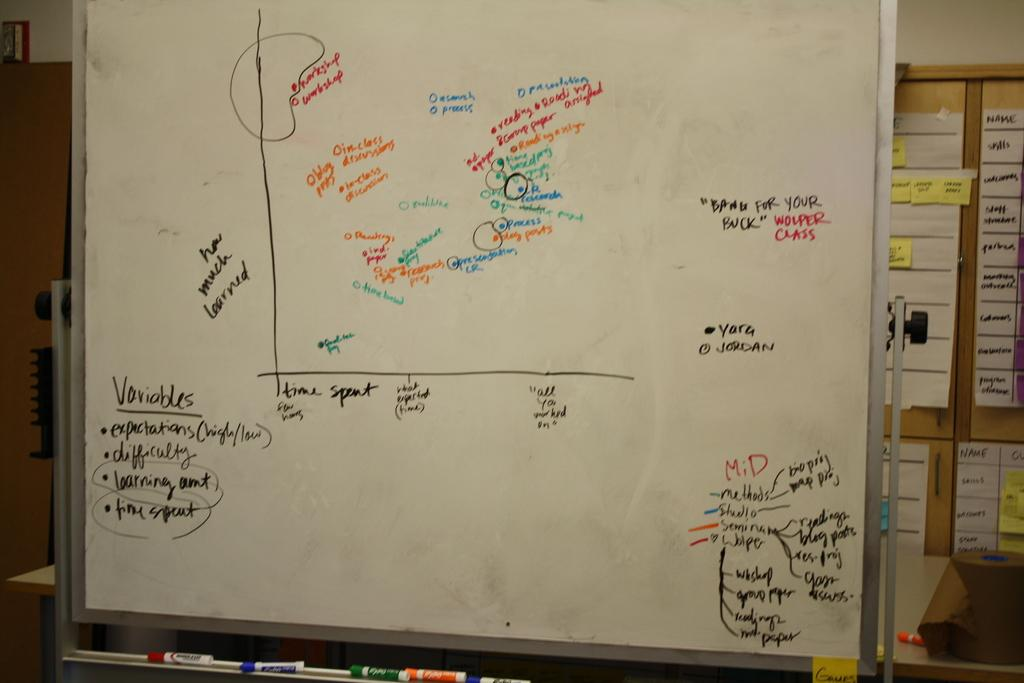<image>
Summarize the visual content of the image. A white board with notes and idea's written on it on how much someone learned and what they learned written in colored markers. 